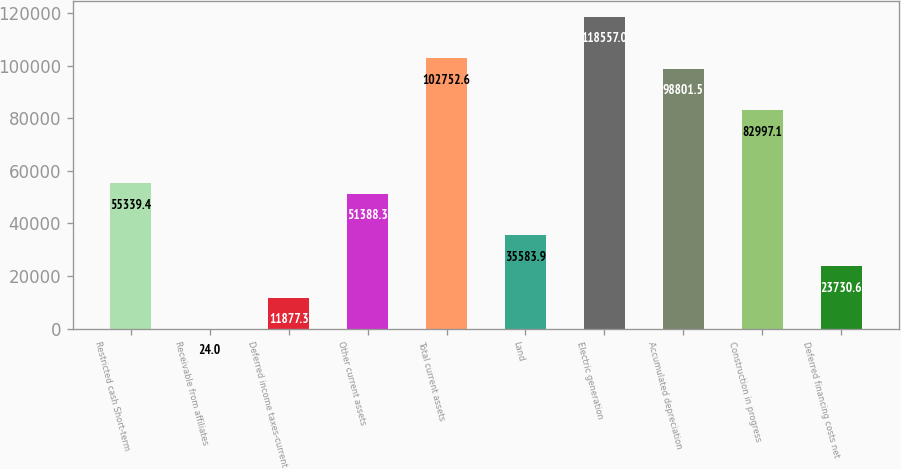Convert chart to OTSL. <chart><loc_0><loc_0><loc_500><loc_500><bar_chart><fcel>Restricted cash Short-term<fcel>Receivable from affiliates<fcel>Deferred income taxes-current<fcel>Other current assets<fcel>Total current assets<fcel>Land<fcel>Electric generation<fcel>Accumulated depreciation<fcel>Construction in progress<fcel>Deferred financing costs net<nl><fcel>55339.4<fcel>24<fcel>11877.3<fcel>51388.3<fcel>102753<fcel>35583.9<fcel>118557<fcel>98801.5<fcel>82997.1<fcel>23730.6<nl></chart> 